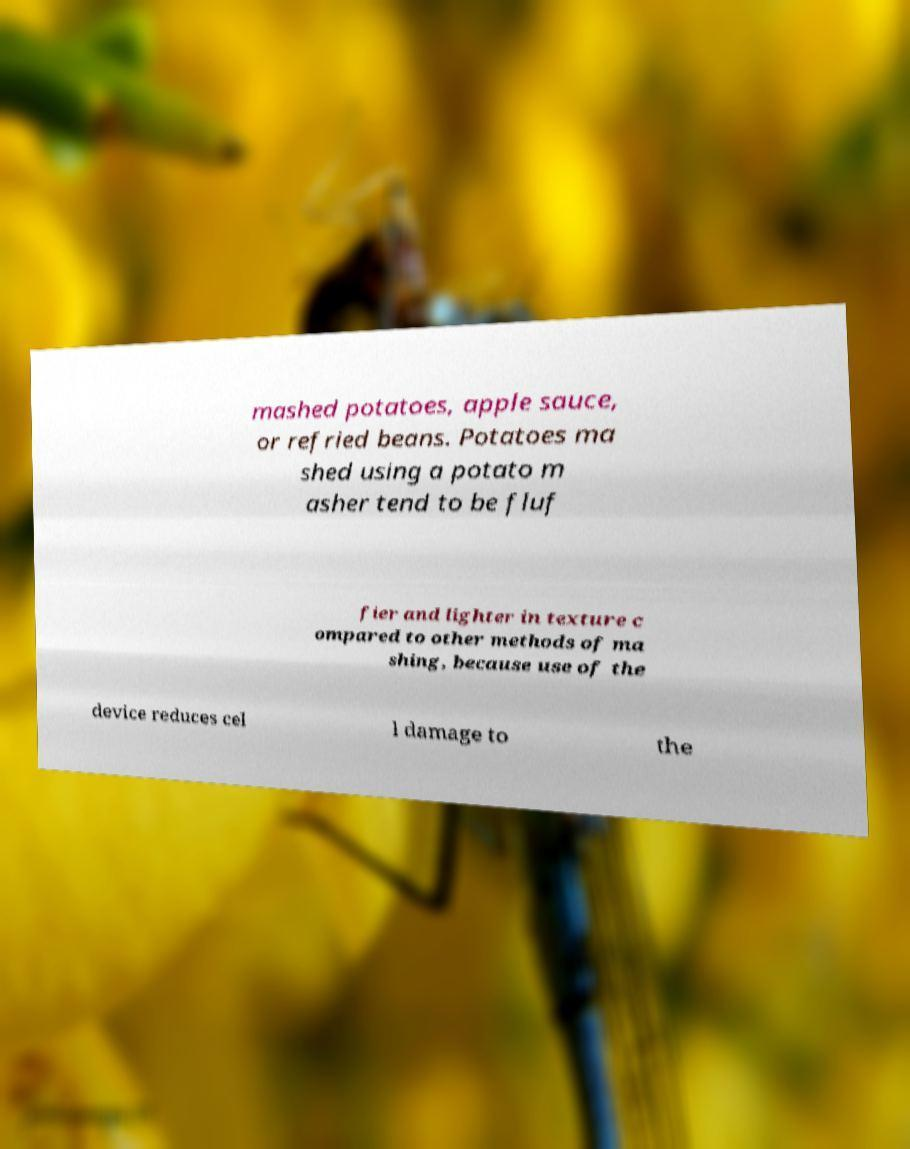Please read and relay the text visible in this image. What does it say? mashed potatoes, apple sauce, or refried beans. Potatoes ma shed using a potato m asher tend to be fluf fier and lighter in texture c ompared to other methods of ma shing, because use of the device reduces cel l damage to the 